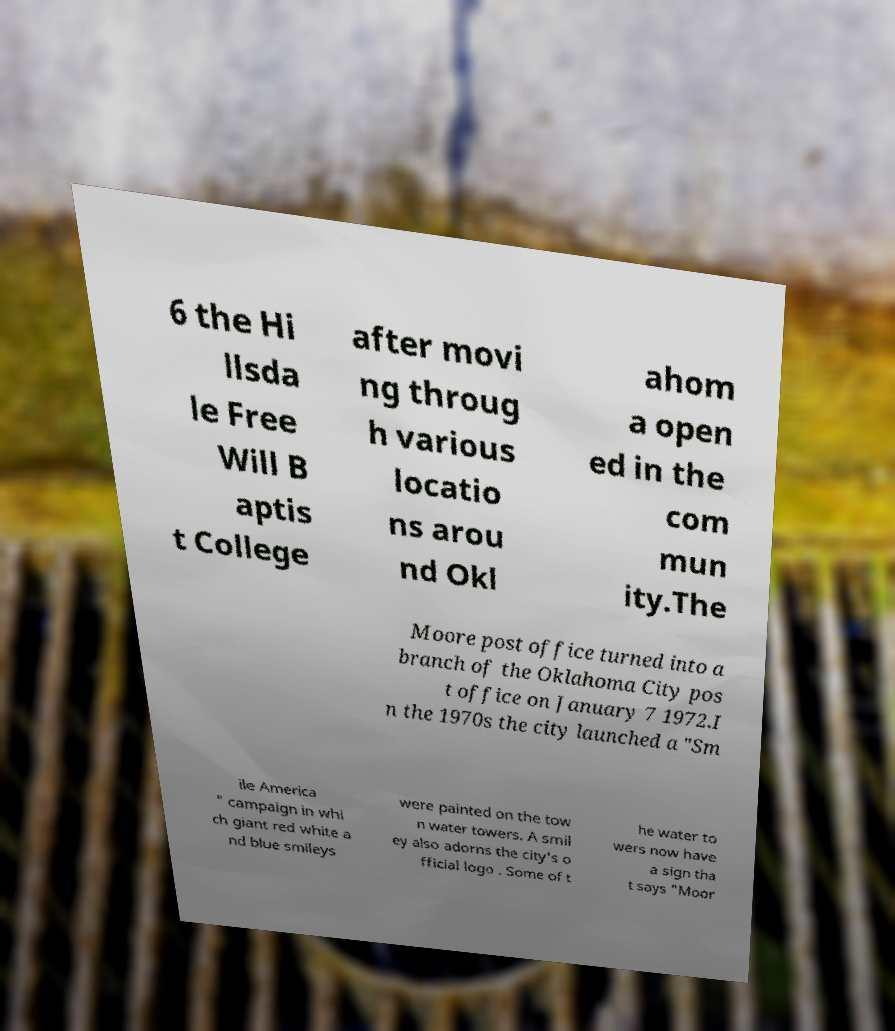Could you assist in decoding the text presented in this image and type it out clearly? 6 the Hi llsda le Free Will B aptis t College after movi ng throug h various locatio ns arou nd Okl ahom a open ed in the com mun ity.The Moore post office turned into a branch of the Oklahoma City pos t office on January 7 1972.I n the 1970s the city launched a "Sm ile America " campaign in whi ch giant red white a nd blue smileys were painted on the tow n water towers. A smil ey also adorns the city's o fficial logo . Some of t he water to wers now have a sign tha t says "Moor 